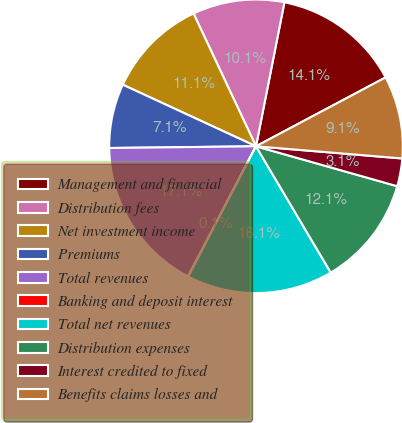Convert chart to OTSL. <chart><loc_0><loc_0><loc_500><loc_500><pie_chart><fcel>Management and financial<fcel>Distribution fees<fcel>Net investment income<fcel>Premiums<fcel>Total revenues<fcel>Banking and deposit interest<fcel>Total net revenues<fcel>Distribution expenses<fcel>Interest credited to fixed<fcel>Benefits claims losses and<nl><fcel>14.12%<fcel>10.1%<fcel>11.11%<fcel>7.08%<fcel>17.14%<fcel>0.05%<fcel>16.13%<fcel>12.11%<fcel>3.06%<fcel>9.1%<nl></chart> 